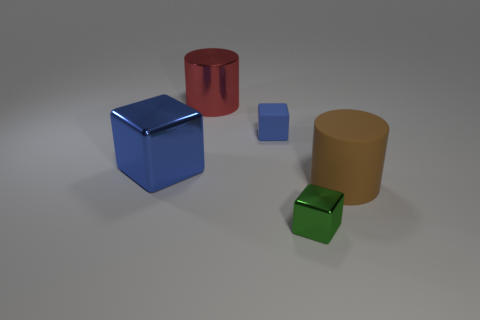Add 5 rubber things. How many objects exist? 10 Subtract all blocks. How many objects are left? 2 Add 2 green things. How many green things are left? 3 Add 4 large yellow rubber cylinders. How many large yellow rubber cylinders exist? 4 Subtract 0 purple spheres. How many objects are left? 5 Subtract all brown objects. Subtract all blue metallic objects. How many objects are left? 3 